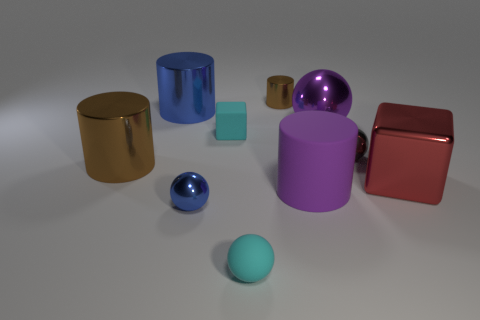How many big matte things are the same shape as the tiny gray thing?
Offer a terse response. 0. The large brown thing is what shape?
Provide a succinct answer. Cylinder. Are there the same number of purple matte cylinders on the left side of the cyan ball and tiny blue things?
Offer a terse response. No. Is there any other thing that is the same material as the big cube?
Offer a terse response. Yes. Do the brown cylinder on the right side of the small blue ball and the big cube have the same material?
Provide a succinct answer. Yes. Are there fewer small rubber spheres behind the purple ball than large green matte cubes?
Keep it short and to the point. No. How many matte things are either cylinders or cyan cylinders?
Your response must be concise. 1. Is the color of the matte cylinder the same as the large cube?
Give a very brief answer. No. Is there any other thing that is the same color as the big ball?
Give a very brief answer. Yes. There is a cyan rubber object in front of the small gray ball; is it the same shape as the object that is to the right of the gray shiny object?
Ensure brevity in your answer.  No. 